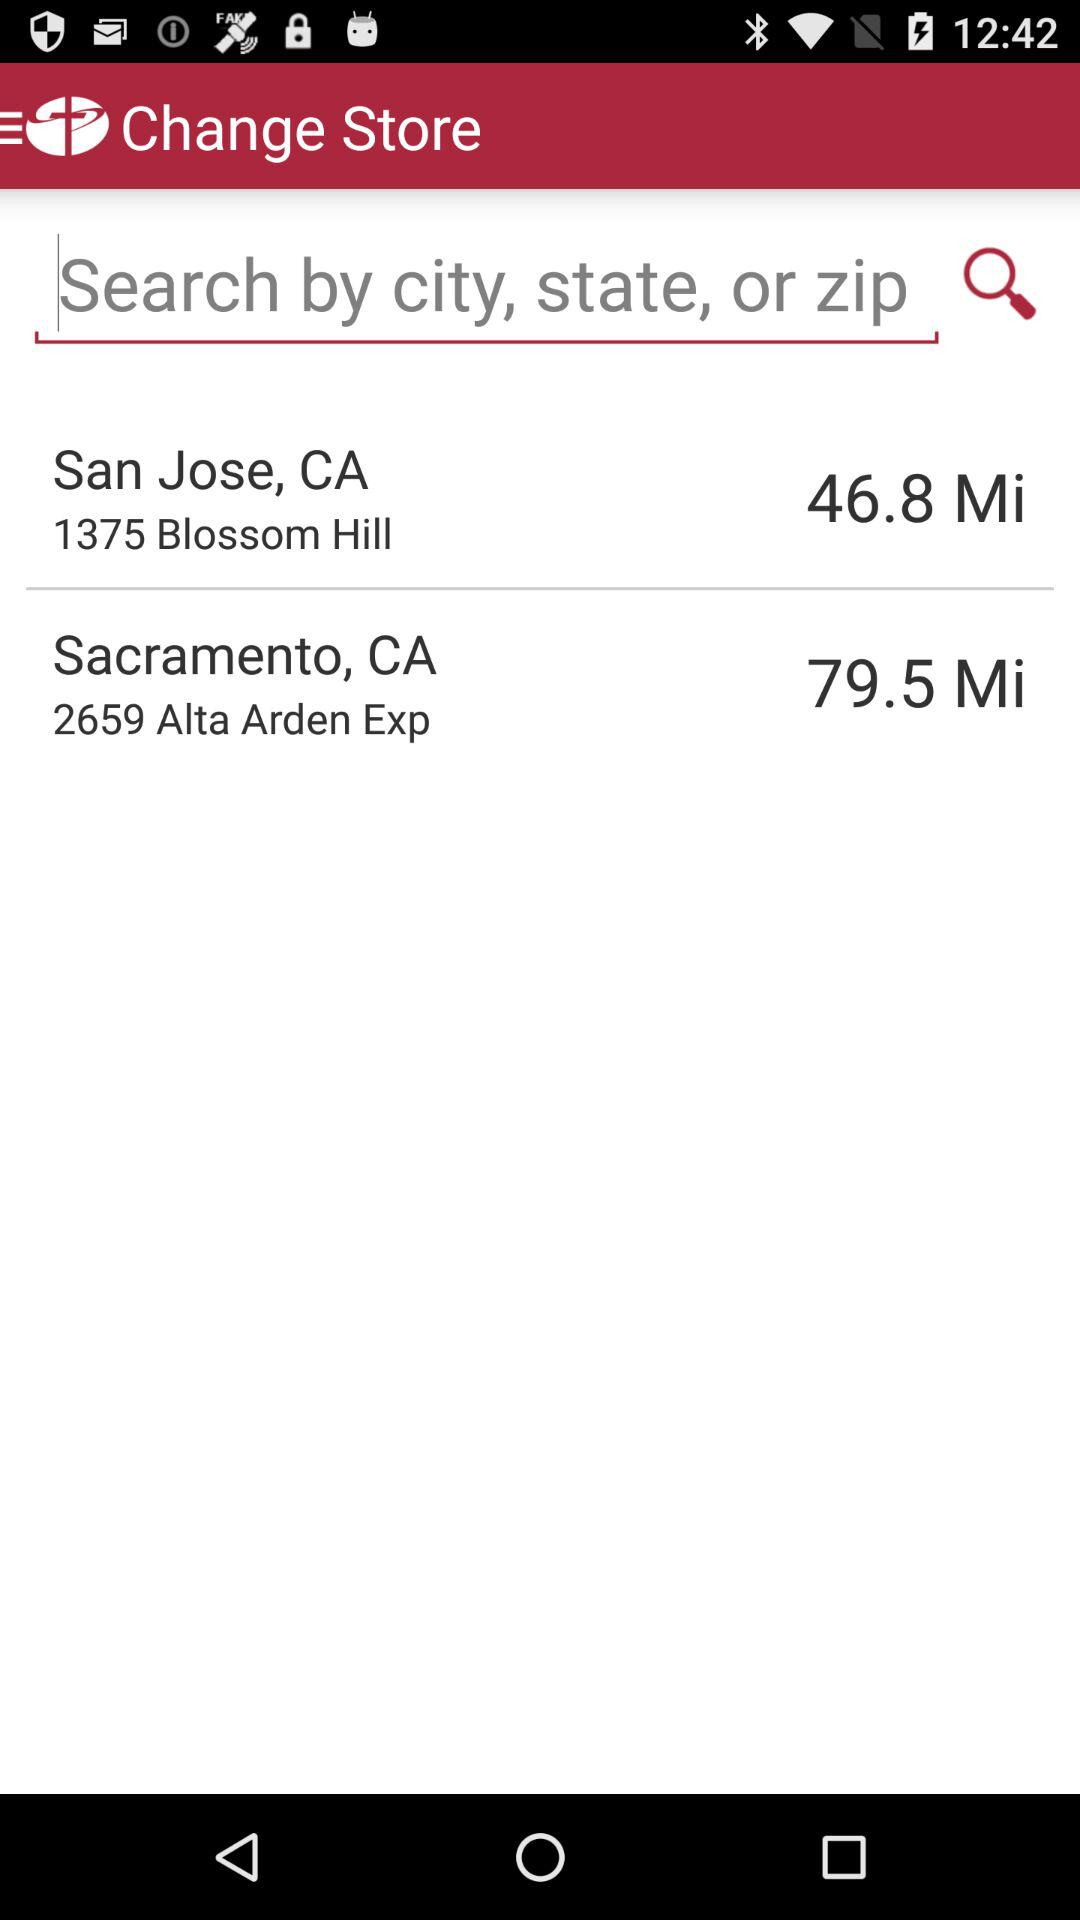What is the location of the store in Sacramento, CA? The location is 2659 Alta Arden Exp. 